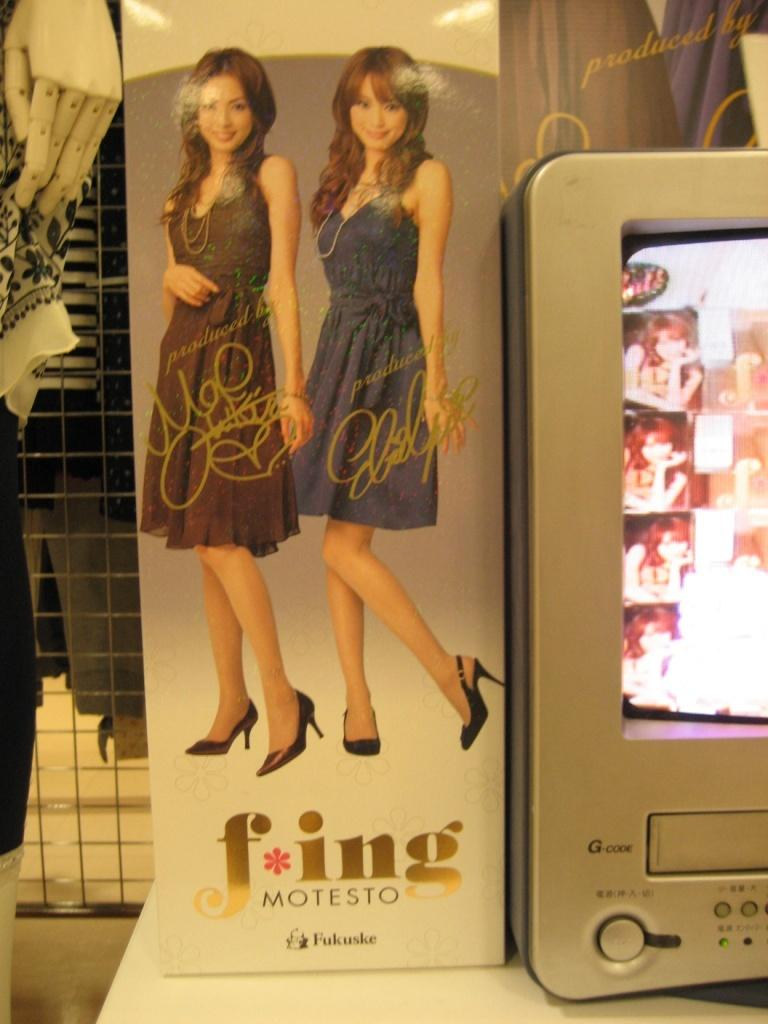What is present on the poster in the image? The poster features two women. What other object can be seen in the image besides the poster? There is a screen in the image. What type of brick is being used to build the house in the image? There is no house or brick present in the image; it only features a poster and a screen. How many babies are visible in the image? There are no babies present in the image. 